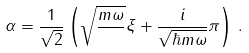Convert formula to latex. <formula><loc_0><loc_0><loc_500><loc_500>\alpha = \frac { 1 } { \sqrt { 2 } } \left ( \sqrt { \frac { m \omega } { } } \xi + \frac { i } { \sqrt { \hbar { m } \omega } } \pi \right ) \, .</formula> 